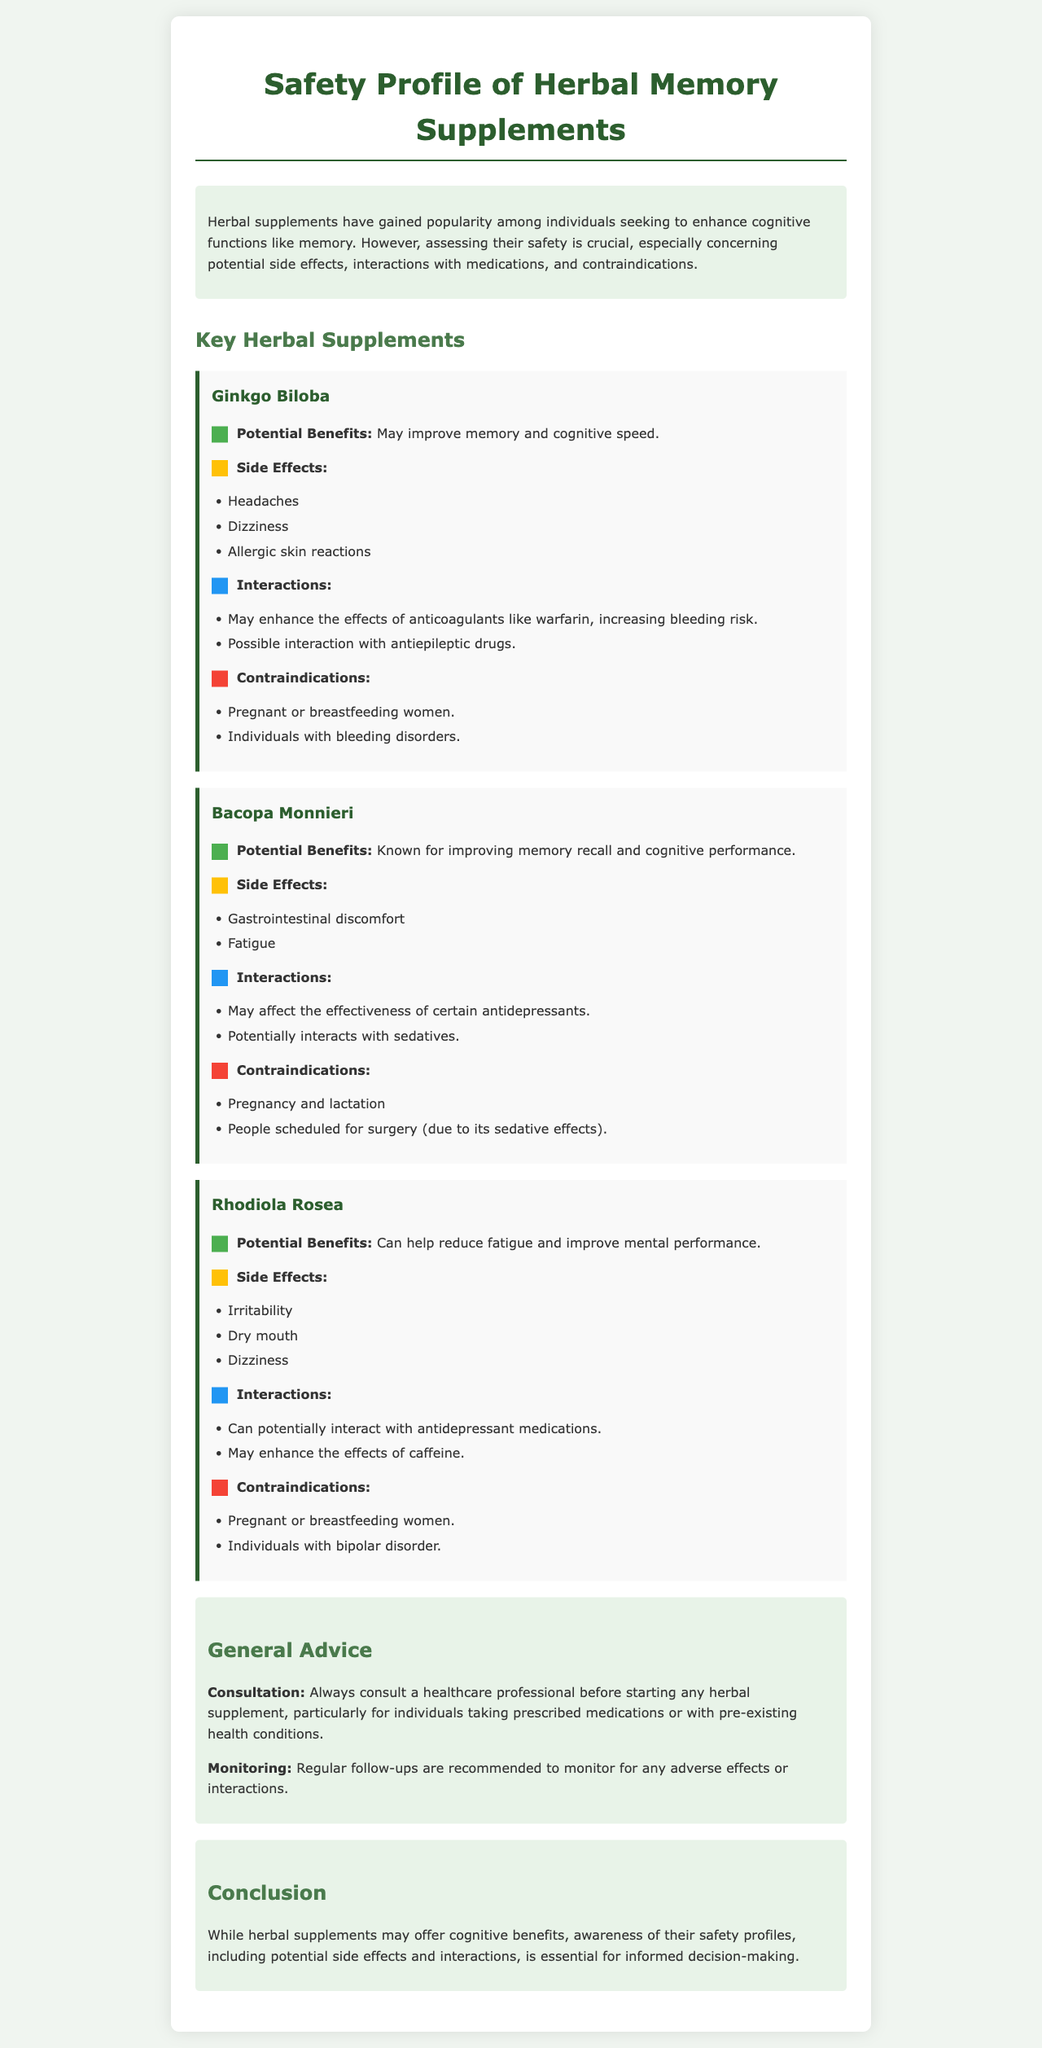What is the title of the report? The title is prominently displayed at the top of the document, indicating the focus of the content.
Answer: Safety Profile of Herbal Memory Supplements Which herbal supplement is known for improving memory recall? This information is found under the section discussing Bacopa Monnieri and its benefits.
Answer: Bacopa Monnieri What are two side effects of Ginkgo Biloba? The side effects are listed under the Ginkgo Biloba section, highlighting potential adverse reactions to the supplement.
Answer: Headaches, Dizziness Which demographic should avoid taking Rhodiola Rosea? This is mentioned in the contraindications related to Rhodiola Rosea, indicating specific groups at risk.
Answer: Pregnant or breastfeeding women What general advice is recommended for starting herbal supplements? The document advises consulting healthcare professionals before beginning supplementation, emphasizing safety.
Answer: Consult a healthcare professional How many key herbal supplements are discussed in the report? The number of supplements can be found by counting the distinct sections for each supplement covered.
Answer: Three 